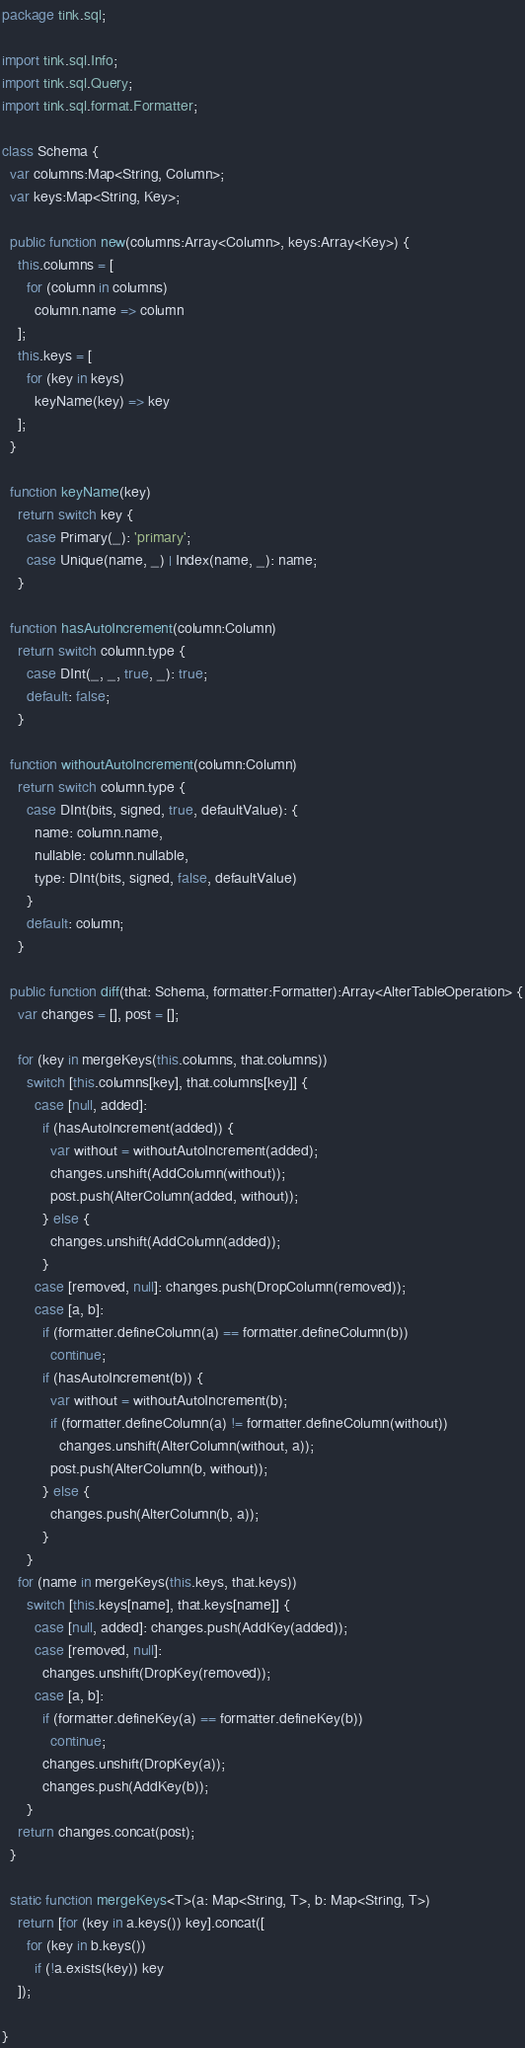<code> <loc_0><loc_0><loc_500><loc_500><_Haxe_>package tink.sql;

import tink.sql.Info;
import tink.sql.Query;
import tink.sql.format.Formatter;

class Schema {
  var columns:Map<String, Column>;
  var keys:Map<String, Key>;

  public function new(columns:Array<Column>, keys:Array<Key>) {
    this.columns = [
      for (column in columns)
        column.name => column
    ];
    this.keys = [
      for (key in keys)
        keyName(key) => key
    ];
  }

  function keyName(key)
    return switch key {
      case Primary(_): 'primary';
      case Unique(name, _) | Index(name, _): name;
    }

  function hasAutoIncrement(column:Column)
    return switch column.type {
      case DInt(_, _, true, _): true;
      default: false;
    }

  function withoutAutoIncrement(column:Column)
    return switch column.type {
      case DInt(bits, signed, true, defaultValue): {
        name: column.name, 
        nullable: column.nullable, 
        type: DInt(bits, signed, false, defaultValue)
      }
      default: column;
    }

  public function diff(that: Schema, formatter:Formatter):Array<AlterTableOperation> {
    var changes = [], post = [];

    for (key in mergeKeys(this.columns, that.columns))
      switch [this.columns[key], that.columns[key]] {
        case [null, added]:
          if (hasAutoIncrement(added)) {
            var without = withoutAutoIncrement(added);
            changes.unshift(AddColumn(without));
            post.push(AlterColumn(added, without));
          } else {
            changes.unshift(AddColumn(added));
          }
        case [removed, null]: changes.push(DropColumn(removed));
        case [a, b]:
          if (formatter.defineColumn(a) == formatter.defineColumn(b))
            continue;
          if (hasAutoIncrement(b)) {
            var without = withoutAutoIncrement(b);
            if (formatter.defineColumn(a) != formatter.defineColumn(without))
              changes.unshift(AlterColumn(without, a));
            post.push(AlterColumn(b, without));
          } else {
            changes.push(AlterColumn(b, a));
          }
      }
    for (name in mergeKeys(this.keys, that.keys))
      switch [this.keys[name], that.keys[name]] {
        case [null, added]: changes.push(AddKey(added));
        case [removed, null]:
          changes.unshift(DropKey(removed));
        case [a, b]:
          if (formatter.defineKey(a) == formatter.defineKey(b))
            continue;
          changes.unshift(DropKey(a));
          changes.push(AddKey(b));
      }
    return changes.concat(post);
  }

  static function mergeKeys<T>(a: Map<String, T>, b: Map<String, T>)
    return [for (key in a.keys()) key].concat([
      for (key in b.keys())
        if (!a.exists(key)) key
    ]);
    
}</code> 